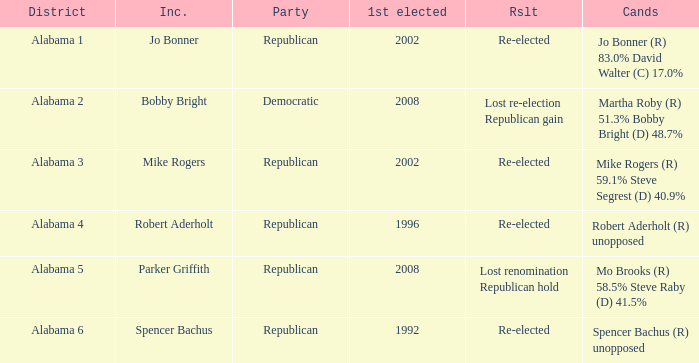Name the incumbent for alabama 6 Spencer Bachus. 